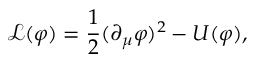Convert formula to latex. <formula><loc_0><loc_0><loc_500><loc_500>\mathcal { L } ( \varphi ) = { \frac { 1 } { 2 } } ( { \partial _ { \mu } \varphi } ) ^ { 2 } - U ( \varphi ) ,</formula> 